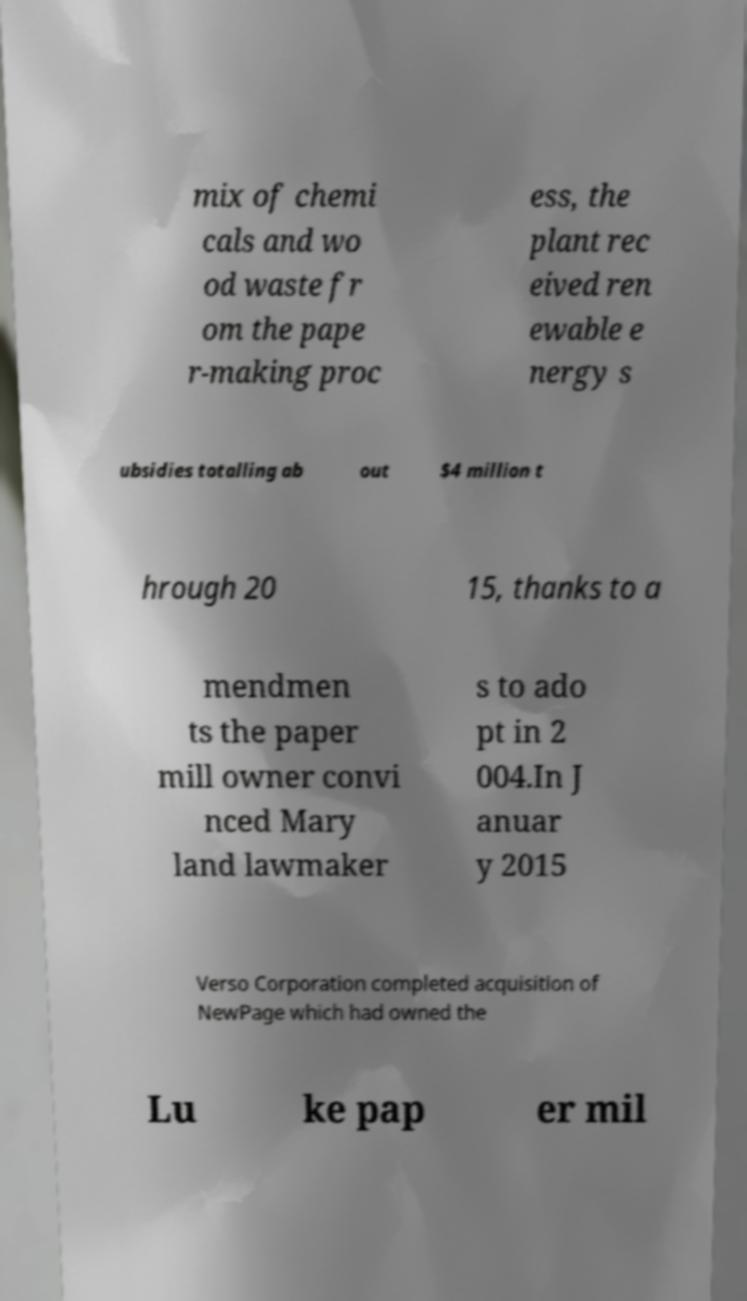There's text embedded in this image that I need extracted. Can you transcribe it verbatim? mix of chemi cals and wo od waste fr om the pape r-making proc ess, the plant rec eived ren ewable e nergy s ubsidies totalling ab out $4 million t hrough 20 15, thanks to a mendmen ts the paper mill owner convi nced Mary land lawmaker s to ado pt in 2 004.In J anuar y 2015 Verso Corporation completed acquisition of NewPage which had owned the Lu ke pap er mil 